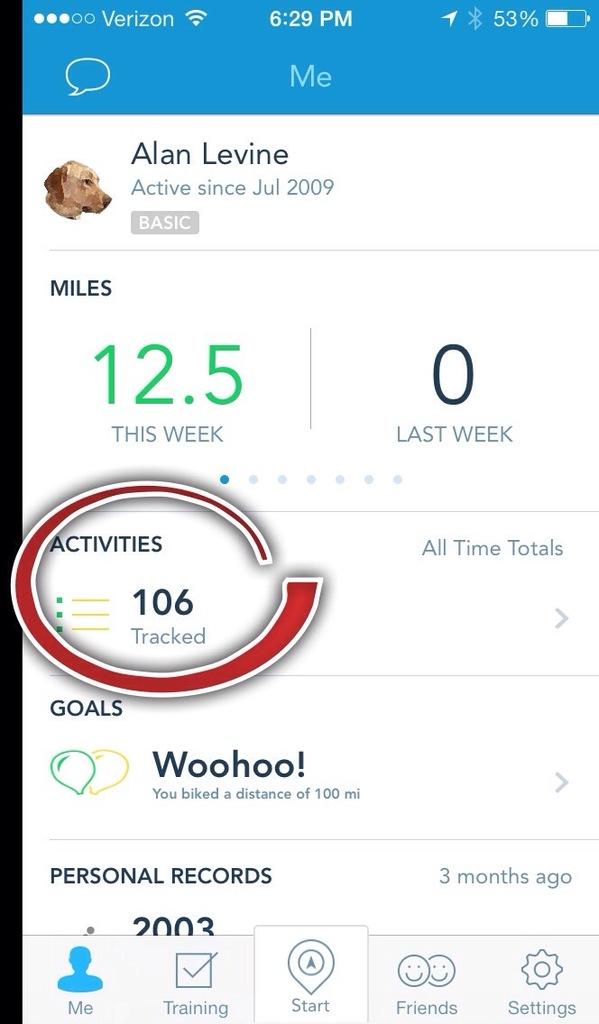What telephone network provider does this mobile phone use?
Your answer should be very brief. Verizon. What time is it on the phone?
Give a very brief answer. 6:29. 